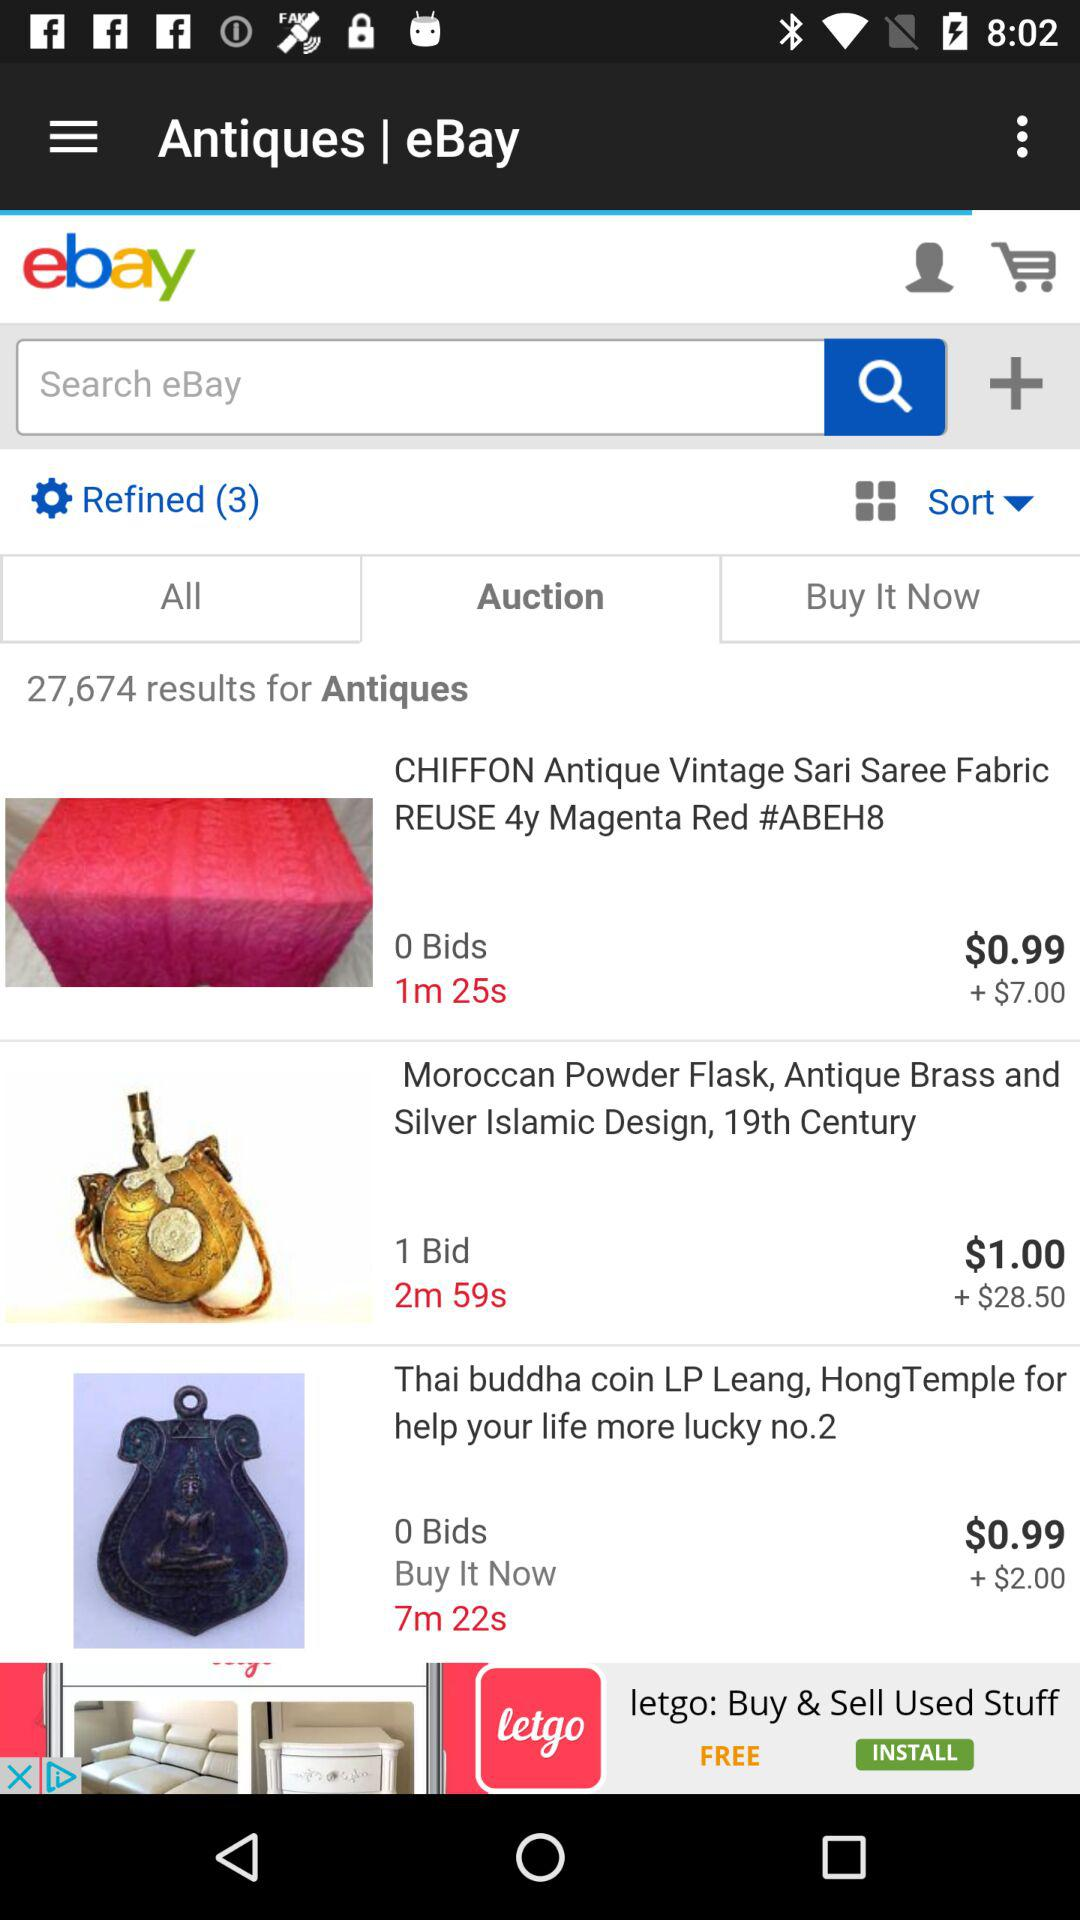What is the price of Thai Buddha coin LP leang,Honng Temple for help your life more lucky no.2?
When the provided information is insufficient, respond with <no answer>. <no answer> 